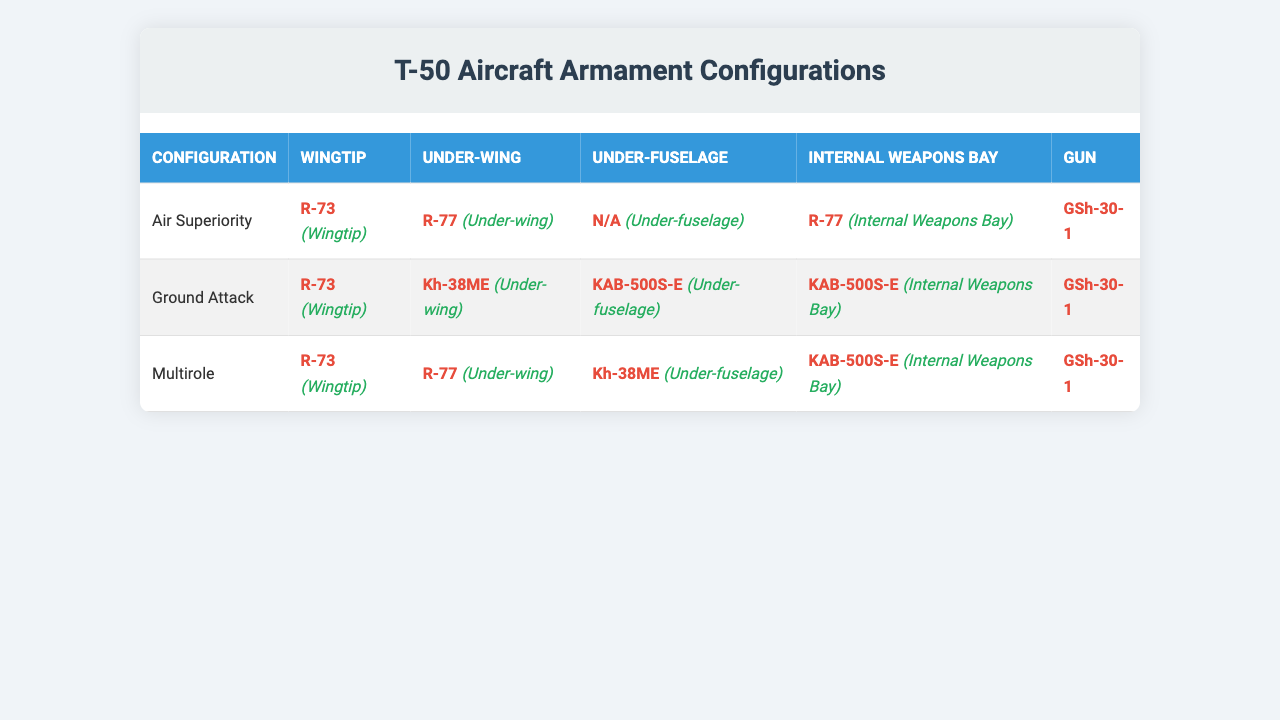What is the configuration that uses the R-77 missile? Referring to the table, the R-77 missile is listed under both the "Air Superiority" and "Multirole" configurations in the "Under-wing" hardpoint.
Answer: Air Superiority and Multirole How many types of configurations are there for the T-50? The table lists three configurations: "Air Superiority," "Ground Attack," and "Multirole." Thus, counting these gives us a total of three distinct configuration types.
Answer: 3 Does the Ground Attack configuration use any air-to-air missiles? Looking at the Ground Attack configuration in the table, it does not use any air-to-air missiles; it has an R-73 at the wingtip, but this missile type is primarily an air-to-air weapon.
Answer: Yes Which configuration allows for the use of the KAB-500S-E? The data shows that both the Ground Attack and Multirole configurations allow for the KAB-500S-E in the "Under-fuselage" and "Internal Weapons Bay" hardpoints.
Answer: Ground Attack and Multirole What is the difference between the Hardpoints used in the Air Superiority and Ground Attack configurations? Comparing the table, the Air Superiority configuration uses R-73 (Wingtip), R-77 (Under-wing), and R-77 (Internal Weapons Bay), while the Ground Attack configuration uses R-73 (Wingtip), Kh-38ME (Under-wing), KAB-500S-E (Under-fuselage), and KAB-500S-E (Internal Weapons Bay). The key difference is that the Air Superiority uses an air-to-air missile (R-77), while the Ground Attack configuration uses air-to-ground missiles (Kh-38ME and KAB-500S-E).
Answer: The configurations differ in the use of air-to-air vs. air-to-ground missiles What is the total count of air-to-ground missiles listed in the table? Referring to the table, the air-to-ground missiles listed are Kh-38ME and KAB-500S-E. There are two distinct air-to-ground missile types mentioned.
Answer: 2 If R-77 is removed from the Air Superiority configuration, what hardpoint is affected? In the Air Superiority configuration, the R-77 is listed under both the "Under-wing" and "Internal Weapons Bay" hardpoints. Removing it would affect both of those hardpoints.
Answer: Two hardpoints are affected 